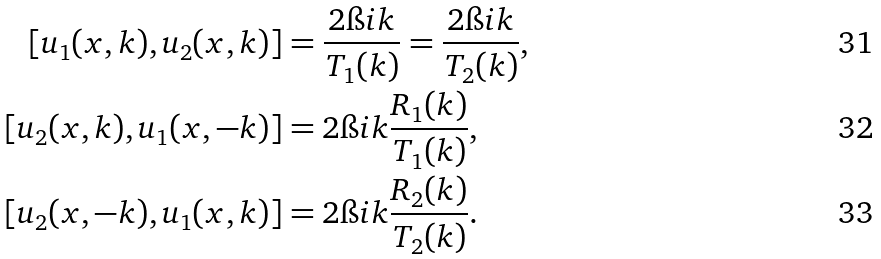Convert formula to latex. <formula><loc_0><loc_0><loc_500><loc_500>[ u _ { 1 } ( x , k ) , u _ { 2 } ( x , k ) ] & = \frac { 2 \i i k } { T _ { 1 } ( k ) } = \frac { 2 \i i k } { T _ { 2 } ( k ) } , \\ [ u _ { 2 } ( x , k ) , u _ { 1 } ( x , - k ) ] & = 2 \i i k \frac { R _ { 1 } ( k ) } { T _ { 1 } ( k ) } , \\ [ u _ { 2 } ( x , - k ) , u _ { 1 } ( x , k ) ] & = 2 \i i k \frac { R _ { 2 } ( k ) } { T _ { 2 } ( k ) } .</formula> 